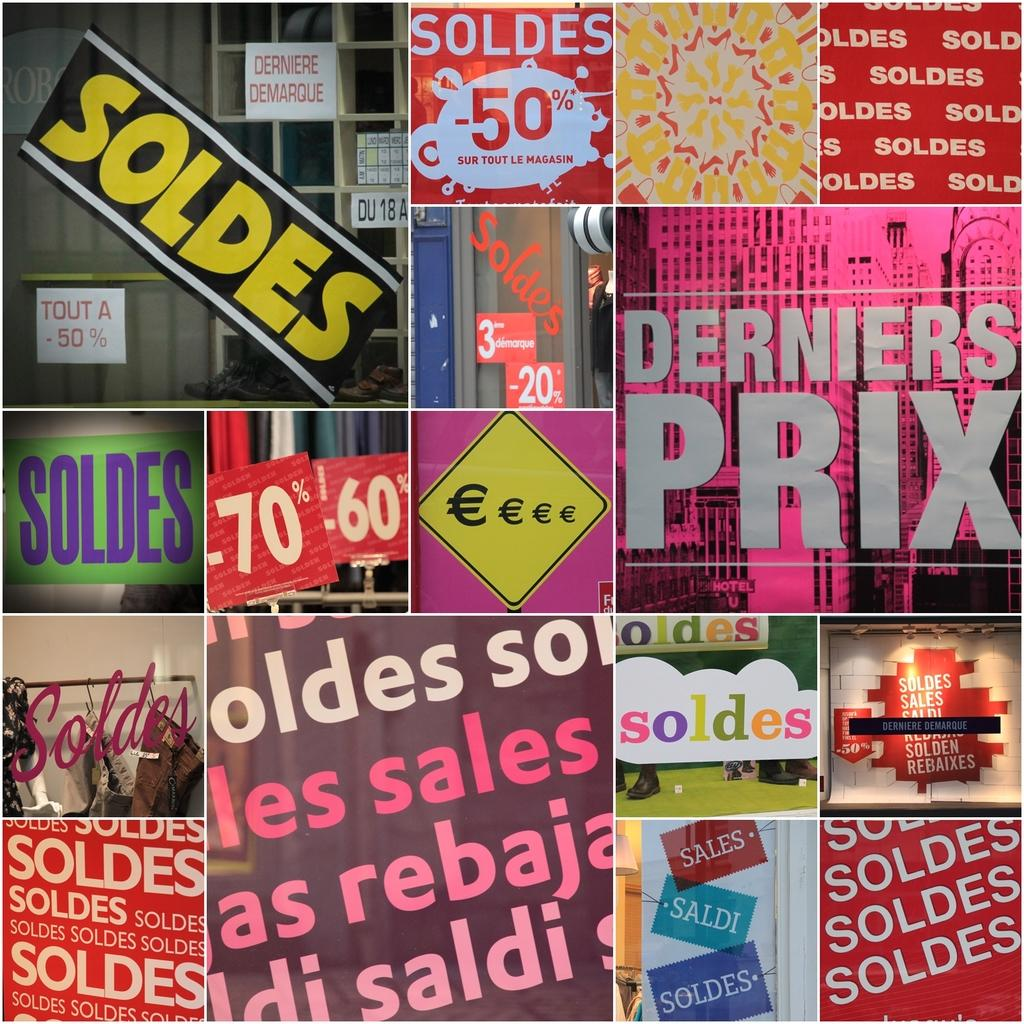<image>
Provide a brief description of the given image. Many images in the collage contain the word soldes. 